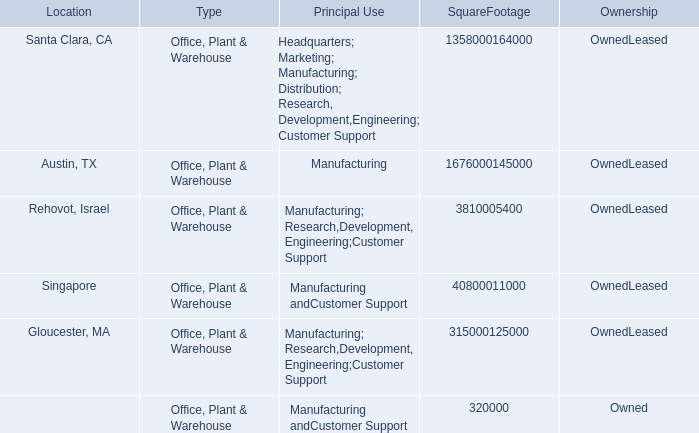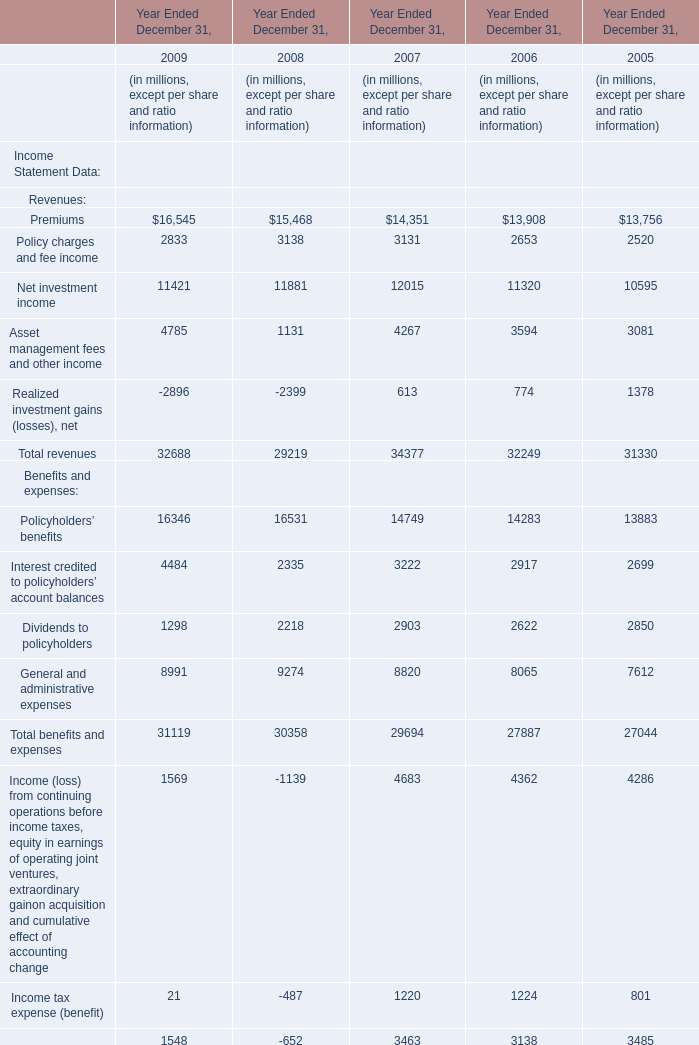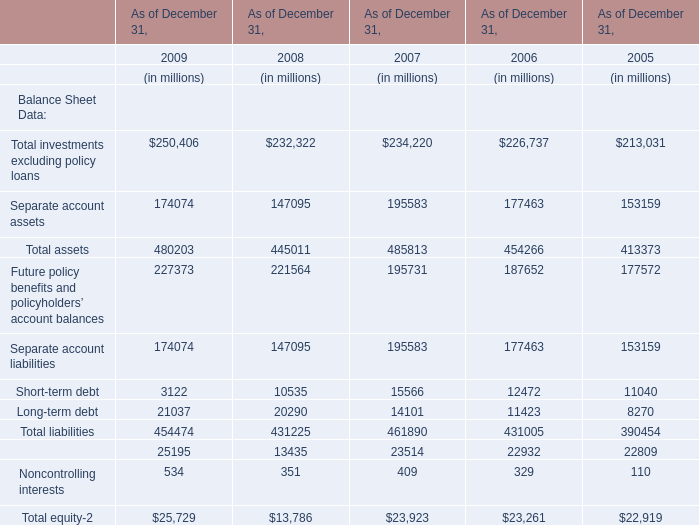What was the average of Policyholders'benefits in 2008, 2007, 2006? (in million) 
Computations: (((16531 + 14749) + 14283) / 3)
Answer: 15187.66667. 